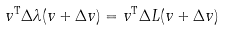Convert formula to latex. <formula><loc_0><loc_0><loc_500><loc_500>v ^ { \text {T} } \Delta \lambda ( v + \Delta v ) = v ^ { \text {T} } \Delta L ( v + \Delta v )</formula> 